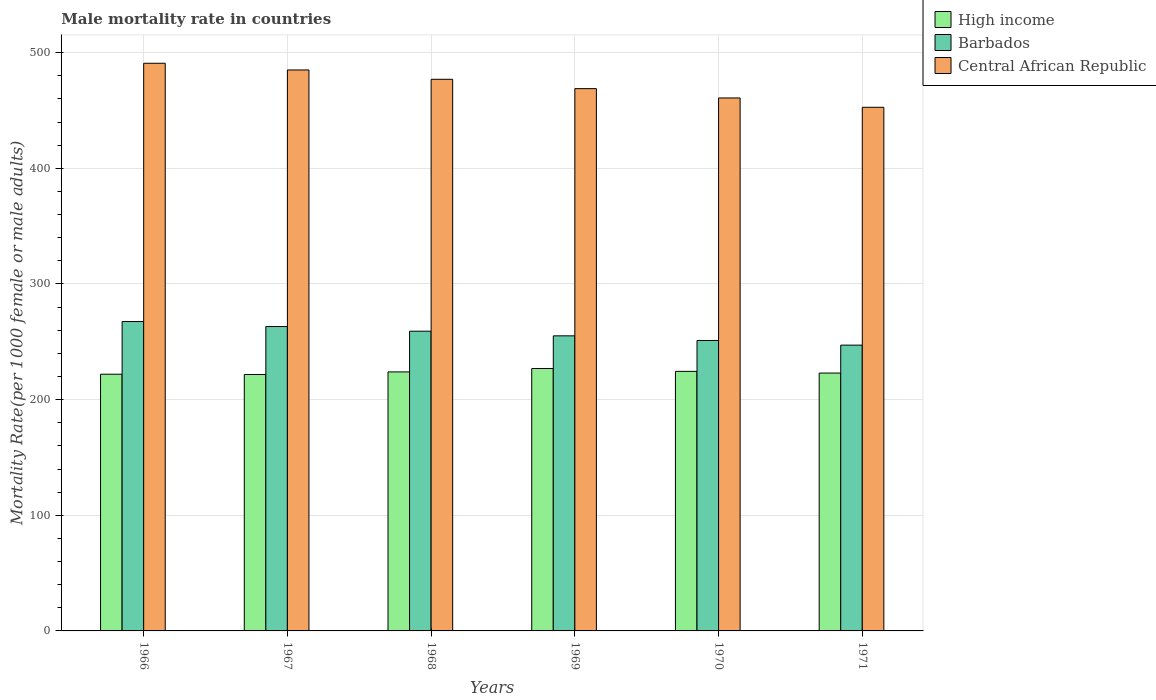How many groups of bars are there?
Make the answer very short. 6. Are the number of bars per tick equal to the number of legend labels?
Make the answer very short. Yes. How many bars are there on the 5th tick from the right?
Ensure brevity in your answer.  3. What is the label of the 1st group of bars from the left?
Make the answer very short. 1966. In how many cases, is the number of bars for a given year not equal to the number of legend labels?
Offer a very short reply. 0. What is the male mortality rate in High income in 1967?
Your answer should be very brief. 221.73. Across all years, what is the maximum male mortality rate in Central African Republic?
Give a very brief answer. 490.87. Across all years, what is the minimum male mortality rate in Central African Republic?
Give a very brief answer. 452.8. In which year was the male mortality rate in Barbados maximum?
Your answer should be very brief. 1966. What is the total male mortality rate in High income in the graph?
Make the answer very short. 1342.01. What is the difference between the male mortality rate in Central African Republic in 1966 and that in 1968?
Offer a terse response. 13.87. What is the difference between the male mortality rate in Central African Republic in 1968 and the male mortality rate in High income in 1966?
Ensure brevity in your answer.  255.02. What is the average male mortality rate in Barbados per year?
Offer a very short reply. 257.23. In the year 1966, what is the difference between the male mortality rate in Central African Republic and male mortality rate in High income?
Your answer should be compact. 268.88. In how many years, is the male mortality rate in Central African Republic greater than 20?
Offer a very short reply. 6. What is the ratio of the male mortality rate in Central African Republic in 1967 to that in 1970?
Offer a terse response. 1.05. What is the difference between the highest and the second highest male mortality rate in Central African Republic?
Ensure brevity in your answer.  5.8. What is the difference between the highest and the lowest male mortality rate in Central African Republic?
Provide a succinct answer. 38.07. What does the 3rd bar from the left in 1971 represents?
Make the answer very short. Central African Republic. What does the 1st bar from the right in 1970 represents?
Offer a terse response. Central African Republic. Is it the case that in every year, the sum of the male mortality rate in Barbados and male mortality rate in High income is greater than the male mortality rate in Central African Republic?
Your response must be concise. No. How many bars are there?
Provide a succinct answer. 18. How many years are there in the graph?
Give a very brief answer. 6. Are the values on the major ticks of Y-axis written in scientific E-notation?
Offer a very short reply. No. How many legend labels are there?
Your answer should be compact. 3. How are the legend labels stacked?
Provide a succinct answer. Vertical. What is the title of the graph?
Offer a very short reply. Male mortality rate in countries. What is the label or title of the X-axis?
Your answer should be compact. Years. What is the label or title of the Y-axis?
Offer a terse response. Mortality Rate(per 1000 female or male adults). What is the Mortality Rate(per 1000 female or male adults) of High income in 1966?
Your response must be concise. 221.98. What is the Mortality Rate(per 1000 female or male adults) in Barbados in 1966?
Provide a succinct answer. 267.53. What is the Mortality Rate(per 1000 female or male adults) of Central African Republic in 1966?
Offer a very short reply. 490.87. What is the Mortality Rate(per 1000 female or male adults) of High income in 1967?
Ensure brevity in your answer.  221.73. What is the Mortality Rate(per 1000 female or male adults) of Barbados in 1967?
Provide a short and direct response. 263.2. What is the Mortality Rate(per 1000 female or male adults) in Central African Republic in 1967?
Provide a short and direct response. 485.07. What is the Mortality Rate(per 1000 female or male adults) in High income in 1968?
Make the answer very short. 223.97. What is the Mortality Rate(per 1000 female or male adults) in Barbados in 1968?
Offer a very short reply. 259.18. What is the Mortality Rate(per 1000 female or male adults) in Central African Republic in 1968?
Make the answer very short. 477. What is the Mortality Rate(per 1000 female or male adults) of High income in 1969?
Ensure brevity in your answer.  226.91. What is the Mortality Rate(per 1000 female or male adults) of Barbados in 1969?
Offer a very short reply. 255.16. What is the Mortality Rate(per 1000 female or male adults) in Central African Republic in 1969?
Give a very brief answer. 468.93. What is the Mortality Rate(per 1000 female or male adults) of High income in 1970?
Your response must be concise. 224.43. What is the Mortality Rate(per 1000 female or male adults) of Barbados in 1970?
Make the answer very short. 251.15. What is the Mortality Rate(per 1000 female or male adults) in Central African Republic in 1970?
Your answer should be very brief. 460.86. What is the Mortality Rate(per 1000 female or male adults) of High income in 1971?
Keep it short and to the point. 222.99. What is the Mortality Rate(per 1000 female or male adults) of Barbados in 1971?
Ensure brevity in your answer.  247.13. What is the Mortality Rate(per 1000 female or male adults) of Central African Republic in 1971?
Your response must be concise. 452.8. Across all years, what is the maximum Mortality Rate(per 1000 female or male adults) of High income?
Offer a very short reply. 226.91. Across all years, what is the maximum Mortality Rate(per 1000 female or male adults) of Barbados?
Offer a terse response. 267.53. Across all years, what is the maximum Mortality Rate(per 1000 female or male adults) in Central African Republic?
Ensure brevity in your answer.  490.87. Across all years, what is the minimum Mortality Rate(per 1000 female or male adults) of High income?
Make the answer very short. 221.73. Across all years, what is the minimum Mortality Rate(per 1000 female or male adults) of Barbados?
Make the answer very short. 247.13. Across all years, what is the minimum Mortality Rate(per 1000 female or male adults) in Central African Republic?
Make the answer very short. 452.8. What is the total Mortality Rate(per 1000 female or male adults) in High income in the graph?
Your response must be concise. 1342.01. What is the total Mortality Rate(per 1000 female or male adults) of Barbados in the graph?
Ensure brevity in your answer.  1543.35. What is the total Mortality Rate(per 1000 female or male adults) in Central African Republic in the graph?
Make the answer very short. 2835.53. What is the difference between the Mortality Rate(per 1000 female or male adults) in High income in 1966 and that in 1967?
Offer a very short reply. 0.26. What is the difference between the Mortality Rate(per 1000 female or male adults) in Barbados in 1966 and that in 1967?
Provide a succinct answer. 4.33. What is the difference between the Mortality Rate(per 1000 female or male adults) of Central African Republic in 1966 and that in 1967?
Offer a terse response. 5.8. What is the difference between the Mortality Rate(per 1000 female or male adults) of High income in 1966 and that in 1968?
Make the answer very short. -1.99. What is the difference between the Mortality Rate(per 1000 female or male adults) in Barbados in 1966 and that in 1968?
Your answer should be compact. 8.34. What is the difference between the Mortality Rate(per 1000 female or male adults) of Central African Republic in 1966 and that in 1968?
Keep it short and to the point. 13.87. What is the difference between the Mortality Rate(per 1000 female or male adults) in High income in 1966 and that in 1969?
Keep it short and to the point. -4.92. What is the difference between the Mortality Rate(per 1000 female or male adults) in Barbados in 1966 and that in 1969?
Your response must be concise. 12.36. What is the difference between the Mortality Rate(per 1000 female or male adults) of Central African Republic in 1966 and that in 1969?
Offer a very short reply. 21.94. What is the difference between the Mortality Rate(per 1000 female or male adults) in High income in 1966 and that in 1970?
Make the answer very short. -2.45. What is the difference between the Mortality Rate(per 1000 female or male adults) of Barbados in 1966 and that in 1970?
Your response must be concise. 16.38. What is the difference between the Mortality Rate(per 1000 female or male adults) of Central African Republic in 1966 and that in 1970?
Your answer should be compact. 30. What is the difference between the Mortality Rate(per 1000 female or male adults) in High income in 1966 and that in 1971?
Offer a very short reply. -1. What is the difference between the Mortality Rate(per 1000 female or male adults) of Barbados in 1966 and that in 1971?
Provide a succinct answer. 20.4. What is the difference between the Mortality Rate(per 1000 female or male adults) of Central African Republic in 1966 and that in 1971?
Your answer should be compact. 38.07. What is the difference between the Mortality Rate(per 1000 female or male adults) of High income in 1967 and that in 1968?
Your answer should be very brief. -2.24. What is the difference between the Mortality Rate(per 1000 female or male adults) of Barbados in 1967 and that in 1968?
Your answer should be compact. 4.02. What is the difference between the Mortality Rate(per 1000 female or male adults) of Central African Republic in 1967 and that in 1968?
Provide a short and direct response. 8.07. What is the difference between the Mortality Rate(per 1000 female or male adults) in High income in 1967 and that in 1969?
Ensure brevity in your answer.  -5.18. What is the difference between the Mortality Rate(per 1000 female or male adults) in Barbados in 1967 and that in 1969?
Make the answer very short. 8.04. What is the difference between the Mortality Rate(per 1000 female or male adults) of Central African Republic in 1967 and that in 1969?
Provide a succinct answer. 16.14. What is the difference between the Mortality Rate(per 1000 female or male adults) in High income in 1967 and that in 1970?
Offer a very short reply. -2.71. What is the difference between the Mortality Rate(per 1000 female or male adults) in Barbados in 1967 and that in 1970?
Give a very brief answer. 12.05. What is the difference between the Mortality Rate(per 1000 female or male adults) of Central African Republic in 1967 and that in 1970?
Offer a terse response. 24.2. What is the difference between the Mortality Rate(per 1000 female or male adults) in High income in 1967 and that in 1971?
Give a very brief answer. -1.26. What is the difference between the Mortality Rate(per 1000 female or male adults) of Barbados in 1967 and that in 1971?
Provide a short and direct response. 16.07. What is the difference between the Mortality Rate(per 1000 female or male adults) of Central African Republic in 1967 and that in 1971?
Offer a terse response. 32.27. What is the difference between the Mortality Rate(per 1000 female or male adults) of High income in 1968 and that in 1969?
Offer a very short reply. -2.94. What is the difference between the Mortality Rate(per 1000 female or male adults) in Barbados in 1968 and that in 1969?
Offer a very short reply. 4.02. What is the difference between the Mortality Rate(per 1000 female or male adults) in Central African Republic in 1968 and that in 1969?
Ensure brevity in your answer.  8.07. What is the difference between the Mortality Rate(per 1000 female or male adults) of High income in 1968 and that in 1970?
Offer a very short reply. -0.46. What is the difference between the Mortality Rate(per 1000 female or male adults) of Barbados in 1968 and that in 1970?
Offer a very short reply. 8.04. What is the difference between the Mortality Rate(per 1000 female or male adults) of Central African Republic in 1968 and that in 1970?
Offer a terse response. 16.14. What is the difference between the Mortality Rate(per 1000 female or male adults) of Barbados in 1968 and that in 1971?
Keep it short and to the point. 12.05. What is the difference between the Mortality Rate(per 1000 female or male adults) in Central African Republic in 1968 and that in 1971?
Your response must be concise. 24.2. What is the difference between the Mortality Rate(per 1000 female or male adults) of High income in 1969 and that in 1970?
Keep it short and to the point. 2.47. What is the difference between the Mortality Rate(per 1000 female or male adults) in Barbados in 1969 and that in 1970?
Provide a succinct answer. 4.02. What is the difference between the Mortality Rate(per 1000 female or male adults) of Central African Republic in 1969 and that in 1970?
Give a very brief answer. 8.07. What is the difference between the Mortality Rate(per 1000 female or male adults) of High income in 1969 and that in 1971?
Provide a succinct answer. 3.92. What is the difference between the Mortality Rate(per 1000 female or male adults) of Barbados in 1969 and that in 1971?
Keep it short and to the point. 8.03. What is the difference between the Mortality Rate(per 1000 female or male adults) of Central African Republic in 1969 and that in 1971?
Your answer should be very brief. 16.14. What is the difference between the Mortality Rate(per 1000 female or male adults) in High income in 1970 and that in 1971?
Offer a terse response. 1.45. What is the difference between the Mortality Rate(per 1000 female or male adults) of Barbados in 1970 and that in 1971?
Your response must be concise. 4.02. What is the difference between the Mortality Rate(per 1000 female or male adults) in Central African Republic in 1970 and that in 1971?
Give a very brief answer. 8.07. What is the difference between the Mortality Rate(per 1000 female or male adults) of High income in 1966 and the Mortality Rate(per 1000 female or male adults) of Barbados in 1967?
Give a very brief answer. -41.22. What is the difference between the Mortality Rate(per 1000 female or male adults) of High income in 1966 and the Mortality Rate(per 1000 female or male adults) of Central African Republic in 1967?
Provide a succinct answer. -263.09. What is the difference between the Mortality Rate(per 1000 female or male adults) of Barbados in 1966 and the Mortality Rate(per 1000 female or male adults) of Central African Republic in 1967?
Keep it short and to the point. -217.54. What is the difference between the Mortality Rate(per 1000 female or male adults) in High income in 1966 and the Mortality Rate(per 1000 female or male adults) in Barbados in 1968?
Give a very brief answer. -37.2. What is the difference between the Mortality Rate(per 1000 female or male adults) in High income in 1966 and the Mortality Rate(per 1000 female or male adults) in Central African Republic in 1968?
Ensure brevity in your answer.  -255.02. What is the difference between the Mortality Rate(per 1000 female or male adults) of Barbados in 1966 and the Mortality Rate(per 1000 female or male adults) of Central African Republic in 1968?
Your response must be concise. -209.47. What is the difference between the Mortality Rate(per 1000 female or male adults) of High income in 1966 and the Mortality Rate(per 1000 female or male adults) of Barbados in 1969?
Make the answer very short. -33.18. What is the difference between the Mortality Rate(per 1000 female or male adults) of High income in 1966 and the Mortality Rate(per 1000 female or male adults) of Central African Republic in 1969?
Offer a terse response. -246.95. What is the difference between the Mortality Rate(per 1000 female or male adults) of Barbados in 1966 and the Mortality Rate(per 1000 female or male adults) of Central African Republic in 1969?
Your answer should be very brief. -201.41. What is the difference between the Mortality Rate(per 1000 female or male adults) in High income in 1966 and the Mortality Rate(per 1000 female or male adults) in Barbados in 1970?
Offer a terse response. -29.16. What is the difference between the Mortality Rate(per 1000 female or male adults) in High income in 1966 and the Mortality Rate(per 1000 female or male adults) in Central African Republic in 1970?
Provide a succinct answer. -238.88. What is the difference between the Mortality Rate(per 1000 female or male adults) of Barbados in 1966 and the Mortality Rate(per 1000 female or male adults) of Central African Republic in 1970?
Your answer should be very brief. -193.34. What is the difference between the Mortality Rate(per 1000 female or male adults) in High income in 1966 and the Mortality Rate(per 1000 female or male adults) in Barbados in 1971?
Your answer should be compact. -25.15. What is the difference between the Mortality Rate(per 1000 female or male adults) in High income in 1966 and the Mortality Rate(per 1000 female or male adults) in Central African Republic in 1971?
Offer a very short reply. -230.81. What is the difference between the Mortality Rate(per 1000 female or male adults) in Barbados in 1966 and the Mortality Rate(per 1000 female or male adults) in Central African Republic in 1971?
Your answer should be compact. -185.27. What is the difference between the Mortality Rate(per 1000 female or male adults) of High income in 1967 and the Mortality Rate(per 1000 female or male adults) of Barbados in 1968?
Your answer should be compact. -37.46. What is the difference between the Mortality Rate(per 1000 female or male adults) in High income in 1967 and the Mortality Rate(per 1000 female or male adults) in Central African Republic in 1968?
Your response must be concise. -255.27. What is the difference between the Mortality Rate(per 1000 female or male adults) of Barbados in 1967 and the Mortality Rate(per 1000 female or male adults) of Central African Republic in 1968?
Offer a terse response. -213.8. What is the difference between the Mortality Rate(per 1000 female or male adults) in High income in 1967 and the Mortality Rate(per 1000 female or male adults) in Barbados in 1969?
Your answer should be compact. -33.44. What is the difference between the Mortality Rate(per 1000 female or male adults) in High income in 1967 and the Mortality Rate(per 1000 female or male adults) in Central African Republic in 1969?
Make the answer very short. -247.2. What is the difference between the Mortality Rate(per 1000 female or male adults) of Barbados in 1967 and the Mortality Rate(per 1000 female or male adults) of Central African Republic in 1969?
Offer a terse response. -205.73. What is the difference between the Mortality Rate(per 1000 female or male adults) of High income in 1967 and the Mortality Rate(per 1000 female or male adults) of Barbados in 1970?
Keep it short and to the point. -29.42. What is the difference between the Mortality Rate(per 1000 female or male adults) in High income in 1967 and the Mortality Rate(per 1000 female or male adults) in Central African Republic in 1970?
Provide a short and direct response. -239.14. What is the difference between the Mortality Rate(per 1000 female or male adults) in Barbados in 1967 and the Mortality Rate(per 1000 female or male adults) in Central African Republic in 1970?
Provide a succinct answer. -197.66. What is the difference between the Mortality Rate(per 1000 female or male adults) in High income in 1967 and the Mortality Rate(per 1000 female or male adults) in Barbados in 1971?
Keep it short and to the point. -25.4. What is the difference between the Mortality Rate(per 1000 female or male adults) in High income in 1967 and the Mortality Rate(per 1000 female or male adults) in Central African Republic in 1971?
Provide a short and direct response. -231.07. What is the difference between the Mortality Rate(per 1000 female or male adults) in Barbados in 1967 and the Mortality Rate(per 1000 female or male adults) in Central African Republic in 1971?
Provide a short and direct response. -189.6. What is the difference between the Mortality Rate(per 1000 female or male adults) of High income in 1968 and the Mortality Rate(per 1000 female or male adults) of Barbados in 1969?
Ensure brevity in your answer.  -31.2. What is the difference between the Mortality Rate(per 1000 female or male adults) of High income in 1968 and the Mortality Rate(per 1000 female or male adults) of Central African Republic in 1969?
Your answer should be compact. -244.96. What is the difference between the Mortality Rate(per 1000 female or male adults) in Barbados in 1968 and the Mortality Rate(per 1000 female or male adults) in Central African Republic in 1969?
Your answer should be compact. -209.75. What is the difference between the Mortality Rate(per 1000 female or male adults) in High income in 1968 and the Mortality Rate(per 1000 female or male adults) in Barbados in 1970?
Keep it short and to the point. -27.18. What is the difference between the Mortality Rate(per 1000 female or male adults) in High income in 1968 and the Mortality Rate(per 1000 female or male adults) in Central African Republic in 1970?
Offer a very short reply. -236.89. What is the difference between the Mortality Rate(per 1000 female or male adults) of Barbados in 1968 and the Mortality Rate(per 1000 female or male adults) of Central African Republic in 1970?
Offer a very short reply. -201.68. What is the difference between the Mortality Rate(per 1000 female or male adults) in High income in 1968 and the Mortality Rate(per 1000 female or male adults) in Barbados in 1971?
Your answer should be compact. -23.16. What is the difference between the Mortality Rate(per 1000 female or male adults) in High income in 1968 and the Mortality Rate(per 1000 female or male adults) in Central African Republic in 1971?
Keep it short and to the point. -228.83. What is the difference between the Mortality Rate(per 1000 female or male adults) in Barbados in 1968 and the Mortality Rate(per 1000 female or male adults) in Central African Republic in 1971?
Ensure brevity in your answer.  -193.61. What is the difference between the Mortality Rate(per 1000 female or male adults) in High income in 1969 and the Mortality Rate(per 1000 female or male adults) in Barbados in 1970?
Provide a short and direct response. -24.24. What is the difference between the Mortality Rate(per 1000 female or male adults) of High income in 1969 and the Mortality Rate(per 1000 female or male adults) of Central African Republic in 1970?
Provide a short and direct response. -233.96. What is the difference between the Mortality Rate(per 1000 female or male adults) of Barbados in 1969 and the Mortality Rate(per 1000 female or male adults) of Central African Republic in 1970?
Your response must be concise. -205.7. What is the difference between the Mortality Rate(per 1000 female or male adults) in High income in 1969 and the Mortality Rate(per 1000 female or male adults) in Barbados in 1971?
Give a very brief answer. -20.22. What is the difference between the Mortality Rate(per 1000 female or male adults) in High income in 1969 and the Mortality Rate(per 1000 female or male adults) in Central African Republic in 1971?
Your answer should be compact. -225.89. What is the difference between the Mortality Rate(per 1000 female or male adults) in Barbados in 1969 and the Mortality Rate(per 1000 female or male adults) in Central African Republic in 1971?
Give a very brief answer. -197.63. What is the difference between the Mortality Rate(per 1000 female or male adults) of High income in 1970 and the Mortality Rate(per 1000 female or male adults) of Barbados in 1971?
Give a very brief answer. -22.7. What is the difference between the Mortality Rate(per 1000 female or male adults) in High income in 1970 and the Mortality Rate(per 1000 female or male adults) in Central African Republic in 1971?
Provide a succinct answer. -228.36. What is the difference between the Mortality Rate(per 1000 female or male adults) of Barbados in 1970 and the Mortality Rate(per 1000 female or male adults) of Central African Republic in 1971?
Offer a very short reply. -201.65. What is the average Mortality Rate(per 1000 female or male adults) of High income per year?
Ensure brevity in your answer.  223.67. What is the average Mortality Rate(per 1000 female or male adults) of Barbados per year?
Offer a very short reply. 257.23. What is the average Mortality Rate(per 1000 female or male adults) of Central African Republic per year?
Provide a succinct answer. 472.59. In the year 1966, what is the difference between the Mortality Rate(per 1000 female or male adults) in High income and Mortality Rate(per 1000 female or male adults) in Barbados?
Offer a terse response. -45.54. In the year 1966, what is the difference between the Mortality Rate(per 1000 female or male adults) in High income and Mortality Rate(per 1000 female or male adults) in Central African Republic?
Make the answer very short. -268.88. In the year 1966, what is the difference between the Mortality Rate(per 1000 female or male adults) in Barbados and Mortality Rate(per 1000 female or male adults) in Central African Republic?
Your answer should be compact. -223.34. In the year 1967, what is the difference between the Mortality Rate(per 1000 female or male adults) in High income and Mortality Rate(per 1000 female or male adults) in Barbados?
Your answer should be compact. -41.47. In the year 1967, what is the difference between the Mortality Rate(per 1000 female or male adults) in High income and Mortality Rate(per 1000 female or male adults) in Central African Republic?
Provide a short and direct response. -263.34. In the year 1967, what is the difference between the Mortality Rate(per 1000 female or male adults) in Barbados and Mortality Rate(per 1000 female or male adults) in Central African Republic?
Ensure brevity in your answer.  -221.87. In the year 1968, what is the difference between the Mortality Rate(per 1000 female or male adults) in High income and Mortality Rate(per 1000 female or male adults) in Barbados?
Your response must be concise. -35.21. In the year 1968, what is the difference between the Mortality Rate(per 1000 female or male adults) of High income and Mortality Rate(per 1000 female or male adults) of Central African Republic?
Your answer should be compact. -253.03. In the year 1968, what is the difference between the Mortality Rate(per 1000 female or male adults) of Barbados and Mortality Rate(per 1000 female or male adults) of Central African Republic?
Give a very brief answer. -217.82. In the year 1969, what is the difference between the Mortality Rate(per 1000 female or male adults) of High income and Mortality Rate(per 1000 female or male adults) of Barbados?
Offer a very short reply. -28.26. In the year 1969, what is the difference between the Mortality Rate(per 1000 female or male adults) of High income and Mortality Rate(per 1000 female or male adults) of Central African Republic?
Offer a terse response. -242.02. In the year 1969, what is the difference between the Mortality Rate(per 1000 female or male adults) in Barbados and Mortality Rate(per 1000 female or male adults) in Central African Republic?
Your answer should be very brief. -213.77. In the year 1970, what is the difference between the Mortality Rate(per 1000 female or male adults) of High income and Mortality Rate(per 1000 female or male adults) of Barbados?
Offer a terse response. -26.71. In the year 1970, what is the difference between the Mortality Rate(per 1000 female or male adults) in High income and Mortality Rate(per 1000 female or male adults) in Central African Republic?
Provide a short and direct response. -236.43. In the year 1970, what is the difference between the Mortality Rate(per 1000 female or male adults) in Barbados and Mortality Rate(per 1000 female or male adults) in Central African Republic?
Your answer should be very brief. -209.72. In the year 1971, what is the difference between the Mortality Rate(per 1000 female or male adults) of High income and Mortality Rate(per 1000 female or male adults) of Barbados?
Give a very brief answer. -24.14. In the year 1971, what is the difference between the Mortality Rate(per 1000 female or male adults) of High income and Mortality Rate(per 1000 female or male adults) of Central African Republic?
Provide a succinct answer. -229.81. In the year 1971, what is the difference between the Mortality Rate(per 1000 female or male adults) of Barbados and Mortality Rate(per 1000 female or male adults) of Central African Republic?
Your answer should be very brief. -205.66. What is the ratio of the Mortality Rate(per 1000 female or male adults) in High income in 1966 to that in 1967?
Offer a terse response. 1. What is the ratio of the Mortality Rate(per 1000 female or male adults) in Barbados in 1966 to that in 1967?
Provide a succinct answer. 1.02. What is the ratio of the Mortality Rate(per 1000 female or male adults) in Central African Republic in 1966 to that in 1967?
Offer a terse response. 1.01. What is the ratio of the Mortality Rate(per 1000 female or male adults) in Barbados in 1966 to that in 1968?
Your response must be concise. 1.03. What is the ratio of the Mortality Rate(per 1000 female or male adults) of Central African Republic in 1966 to that in 1968?
Your response must be concise. 1.03. What is the ratio of the Mortality Rate(per 1000 female or male adults) of High income in 1966 to that in 1969?
Offer a terse response. 0.98. What is the ratio of the Mortality Rate(per 1000 female or male adults) in Barbados in 1966 to that in 1969?
Your answer should be compact. 1.05. What is the ratio of the Mortality Rate(per 1000 female or male adults) in Central African Republic in 1966 to that in 1969?
Offer a very short reply. 1.05. What is the ratio of the Mortality Rate(per 1000 female or male adults) in High income in 1966 to that in 1970?
Offer a terse response. 0.99. What is the ratio of the Mortality Rate(per 1000 female or male adults) in Barbados in 1966 to that in 1970?
Make the answer very short. 1.07. What is the ratio of the Mortality Rate(per 1000 female or male adults) in Central African Republic in 1966 to that in 1970?
Provide a succinct answer. 1.07. What is the ratio of the Mortality Rate(per 1000 female or male adults) of High income in 1966 to that in 1971?
Your answer should be compact. 1. What is the ratio of the Mortality Rate(per 1000 female or male adults) in Barbados in 1966 to that in 1971?
Your answer should be very brief. 1.08. What is the ratio of the Mortality Rate(per 1000 female or male adults) of Central African Republic in 1966 to that in 1971?
Keep it short and to the point. 1.08. What is the ratio of the Mortality Rate(per 1000 female or male adults) of Barbados in 1967 to that in 1968?
Make the answer very short. 1.02. What is the ratio of the Mortality Rate(per 1000 female or male adults) of Central African Republic in 1967 to that in 1968?
Give a very brief answer. 1.02. What is the ratio of the Mortality Rate(per 1000 female or male adults) in High income in 1967 to that in 1969?
Your answer should be compact. 0.98. What is the ratio of the Mortality Rate(per 1000 female or male adults) in Barbados in 1967 to that in 1969?
Offer a very short reply. 1.03. What is the ratio of the Mortality Rate(per 1000 female or male adults) of Central African Republic in 1967 to that in 1969?
Your response must be concise. 1.03. What is the ratio of the Mortality Rate(per 1000 female or male adults) of High income in 1967 to that in 1970?
Provide a succinct answer. 0.99. What is the ratio of the Mortality Rate(per 1000 female or male adults) of Barbados in 1967 to that in 1970?
Make the answer very short. 1.05. What is the ratio of the Mortality Rate(per 1000 female or male adults) of Central African Republic in 1967 to that in 1970?
Provide a short and direct response. 1.05. What is the ratio of the Mortality Rate(per 1000 female or male adults) of High income in 1967 to that in 1971?
Your answer should be compact. 0.99. What is the ratio of the Mortality Rate(per 1000 female or male adults) in Barbados in 1967 to that in 1971?
Offer a terse response. 1.06. What is the ratio of the Mortality Rate(per 1000 female or male adults) in Central African Republic in 1967 to that in 1971?
Provide a short and direct response. 1.07. What is the ratio of the Mortality Rate(per 1000 female or male adults) in High income in 1968 to that in 1969?
Make the answer very short. 0.99. What is the ratio of the Mortality Rate(per 1000 female or male adults) in Barbados in 1968 to that in 1969?
Offer a terse response. 1.02. What is the ratio of the Mortality Rate(per 1000 female or male adults) in Central African Republic in 1968 to that in 1969?
Give a very brief answer. 1.02. What is the ratio of the Mortality Rate(per 1000 female or male adults) in High income in 1968 to that in 1970?
Offer a terse response. 1. What is the ratio of the Mortality Rate(per 1000 female or male adults) in Barbados in 1968 to that in 1970?
Offer a terse response. 1.03. What is the ratio of the Mortality Rate(per 1000 female or male adults) in Central African Republic in 1968 to that in 1970?
Your answer should be compact. 1.03. What is the ratio of the Mortality Rate(per 1000 female or male adults) in High income in 1968 to that in 1971?
Offer a terse response. 1. What is the ratio of the Mortality Rate(per 1000 female or male adults) in Barbados in 1968 to that in 1971?
Your answer should be very brief. 1.05. What is the ratio of the Mortality Rate(per 1000 female or male adults) of Central African Republic in 1968 to that in 1971?
Your answer should be very brief. 1.05. What is the ratio of the Mortality Rate(per 1000 female or male adults) of High income in 1969 to that in 1970?
Offer a terse response. 1.01. What is the ratio of the Mortality Rate(per 1000 female or male adults) of Barbados in 1969 to that in 1970?
Offer a very short reply. 1.02. What is the ratio of the Mortality Rate(per 1000 female or male adults) in Central African Republic in 1969 to that in 1970?
Provide a succinct answer. 1.02. What is the ratio of the Mortality Rate(per 1000 female or male adults) of High income in 1969 to that in 1971?
Provide a succinct answer. 1.02. What is the ratio of the Mortality Rate(per 1000 female or male adults) in Barbados in 1969 to that in 1971?
Your response must be concise. 1.03. What is the ratio of the Mortality Rate(per 1000 female or male adults) in Central African Republic in 1969 to that in 1971?
Provide a short and direct response. 1.04. What is the ratio of the Mortality Rate(per 1000 female or male adults) in Barbados in 1970 to that in 1971?
Provide a short and direct response. 1.02. What is the ratio of the Mortality Rate(per 1000 female or male adults) in Central African Republic in 1970 to that in 1971?
Offer a very short reply. 1.02. What is the difference between the highest and the second highest Mortality Rate(per 1000 female or male adults) of High income?
Your answer should be compact. 2.47. What is the difference between the highest and the second highest Mortality Rate(per 1000 female or male adults) in Barbados?
Provide a succinct answer. 4.33. What is the difference between the highest and the second highest Mortality Rate(per 1000 female or male adults) of Central African Republic?
Give a very brief answer. 5.8. What is the difference between the highest and the lowest Mortality Rate(per 1000 female or male adults) of High income?
Provide a succinct answer. 5.18. What is the difference between the highest and the lowest Mortality Rate(per 1000 female or male adults) in Barbados?
Provide a short and direct response. 20.4. What is the difference between the highest and the lowest Mortality Rate(per 1000 female or male adults) in Central African Republic?
Offer a very short reply. 38.07. 